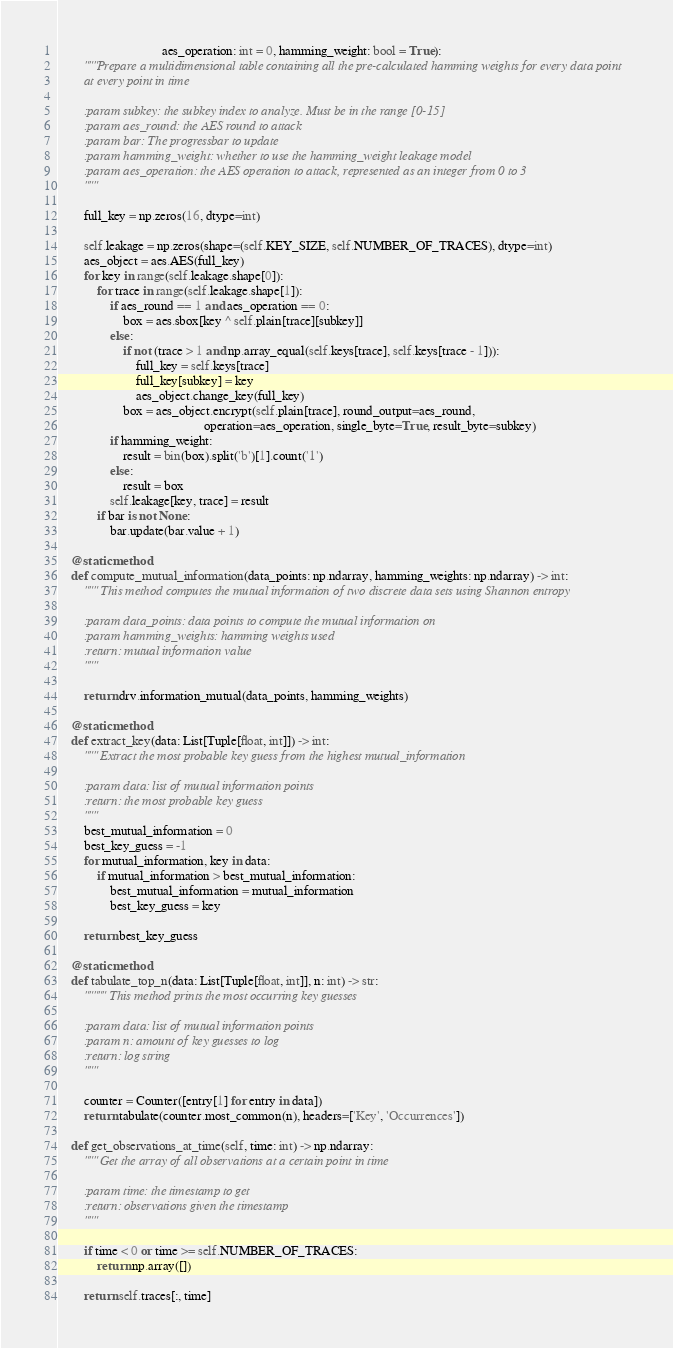<code> <loc_0><loc_0><loc_500><loc_500><_Python_>                                aes_operation: int = 0, hamming_weight: bool = True):
        """Prepare a multidimensional table containing all the pre-calculated hamming weights for every data point
        at every point in time

        :param subkey: the subkey index to analyze. Must be in the range [0-15]
        :param aes_round: the AES round to attack
        :param bar: The progressbar to update
        :param hamming_weight: whether to use the hamming_weight leakage model
        :param aes_operation: the AES operation to attack, represented as an integer from 0 to 3
        """

        full_key = np.zeros(16, dtype=int)

        self.leakage = np.zeros(shape=(self.KEY_SIZE, self.NUMBER_OF_TRACES), dtype=int)
        aes_object = aes.AES(full_key)
        for key in range(self.leakage.shape[0]):
            for trace in range(self.leakage.shape[1]):
                if aes_round == 1 and aes_operation == 0:
                    box = aes.sbox[key ^ self.plain[trace][subkey]]
                else:
                    if not (trace > 1 and np.array_equal(self.keys[trace], self.keys[trace - 1])):
                        full_key = self.keys[trace]
                        full_key[subkey] = key
                        aes_object.change_key(full_key)
                    box = aes_object.encrypt(self.plain[trace], round_output=aes_round,
                                             operation=aes_operation, single_byte=True, result_byte=subkey)
                if hamming_weight:
                    result = bin(box).split('b')[1].count('1')
                else:
                    result = box
                self.leakage[key, trace] = result
            if bar is not None:
                bar.update(bar.value + 1)

    @staticmethod
    def compute_mutual_information(data_points: np.ndarray, hamming_weights: np.ndarray) -> int:
        """ This method computes the mutual information of two discrete data sets using Shannon entropy

        :param data_points: data points to compute the mutual information on
        :param hamming_weights: hamming weights used
        :return: mutual information value
        """

        return drv.information_mutual(data_points, hamming_weights)

    @staticmethod
    def extract_key(data: List[Tuple[float, int]]) -> int:
        """ Extract the most probable key guess from the highest mutual_information

        :param data: list of mutual information points
        :return: the most probable key guess
        """
        best_mutual_information = 0
        best_key_guess = -1
        for mutual_information, key in data:
            if mutual_information > best_mutual_information:
                best_mutual_information = mutual_information
                best_key_guess = key

        return best_key_guess

    @staticmethod
    def tabulate_top_n(data: List[Tuple[float, int]], n: int) -> str:
        """"" This method prints the most occurring key guesses

        :param data: list of mutual information points
        :param n: amount of key guesses to log
        :return: log string
        """

        counter = Counter([entry[1] for entry in data])
        return tabulate(counter.most_common(n), headers=['Key', 'Occurrences'])

    def get_observations_at_time(self, time: int) -> np.ndarray:
        """ Get the array of all observations at a certain point in time

        :param time: the timestamp to get
        :return: observations given the timestamp
        """

        if time < 0 or time >= self.NUMBER_OF_TRACES:
            return np.array([])

        return self.traces[:, time]
</code> 